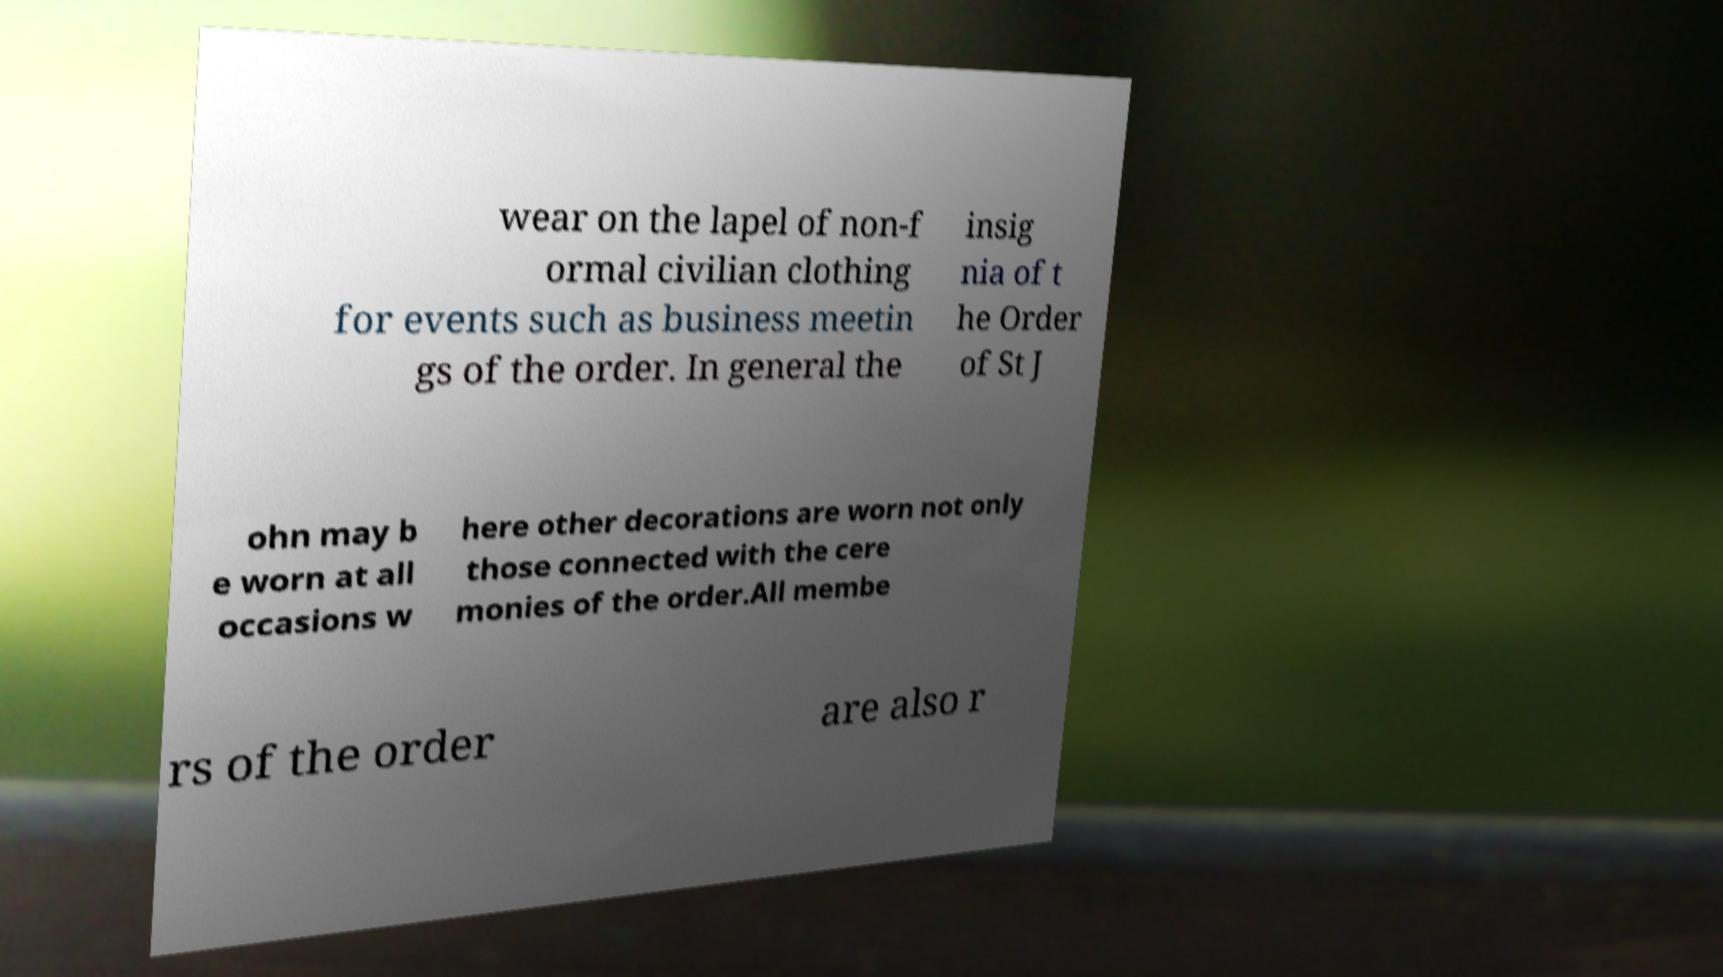Please identify and transcribe the text found in this image. wear on the lapel of non-f ormal civilian clothing for events such as business meetin gs of the order. In general the insig nia of t he Order of St J ohn may b e worn at all occasions w here other decorations are worn not only those connected with the cere monies of the order.All membe rs of the order are also r 